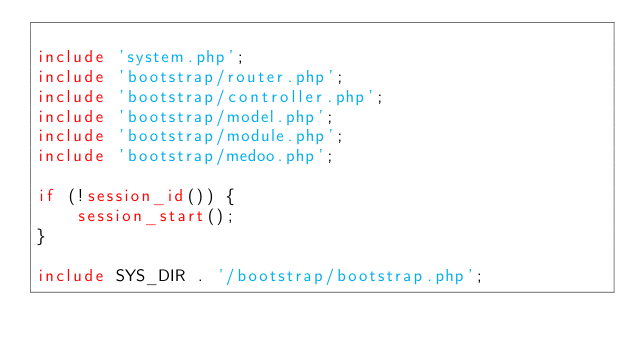<code> <loc_0><loc_0><loc_500><loc_500><_PHP_>
include 'system.php';
include 'bootstrap/router.php';
include 'bootstrap/controller.php';
include 'bootstrap/model.php';
include 'bootstrap/module.php';
include 'bootstrap/medoo.php';

if (!session_id()) {
	session_start();
}

include SYS_DIR . '/bootstrap/bootstrap.php';</code> 